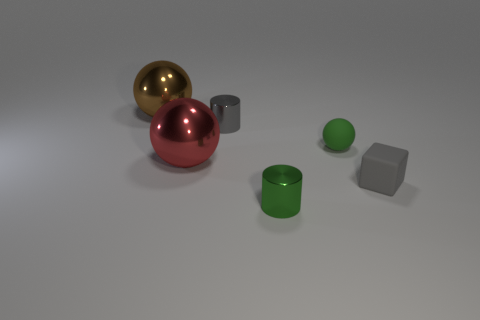Subtract all tiny spheres. How many spheres are left? 2 Add 1 large red metal spheres. How many objects exist? 7 Subtract all cylinders. How many objects are left? 4 Subtract 0 purple cylinders. How many objects are left? 6 Subtract all rubber balls. Subtract all red metal spheres. How many objects are left? 4 Add 6 red balls. How many red balls are left? 7 Add 6 brown metallic things. How many brown metallic things exist? 7 